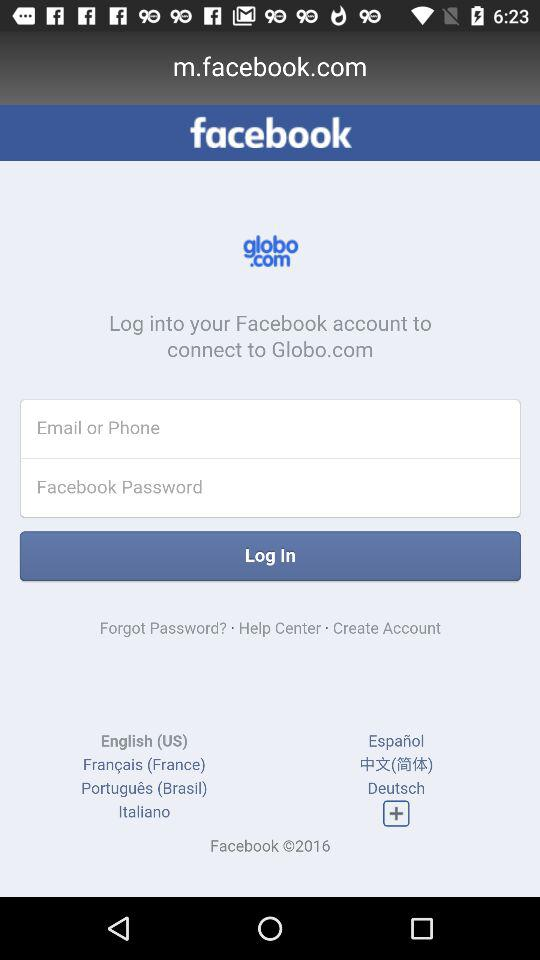What is the application name? The application name is "facebook". 